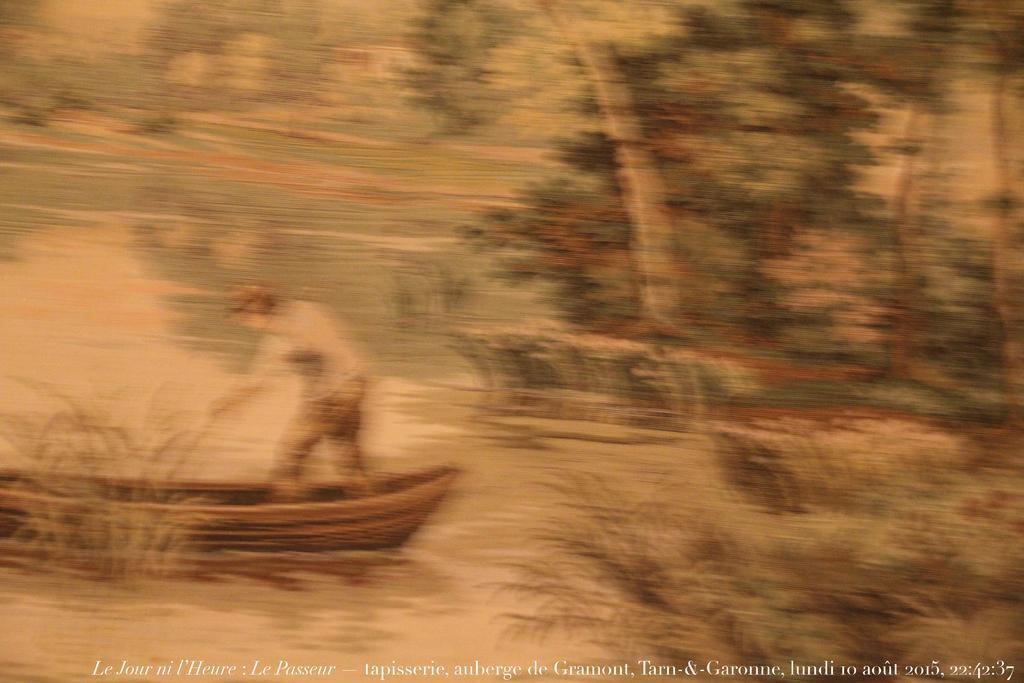Describe this image in one or two sentences. This image consists of a painting. On the left side, I can see a person is standing on the boat. On the right side there are some plants. At the bottom of this painting I can see some text. 